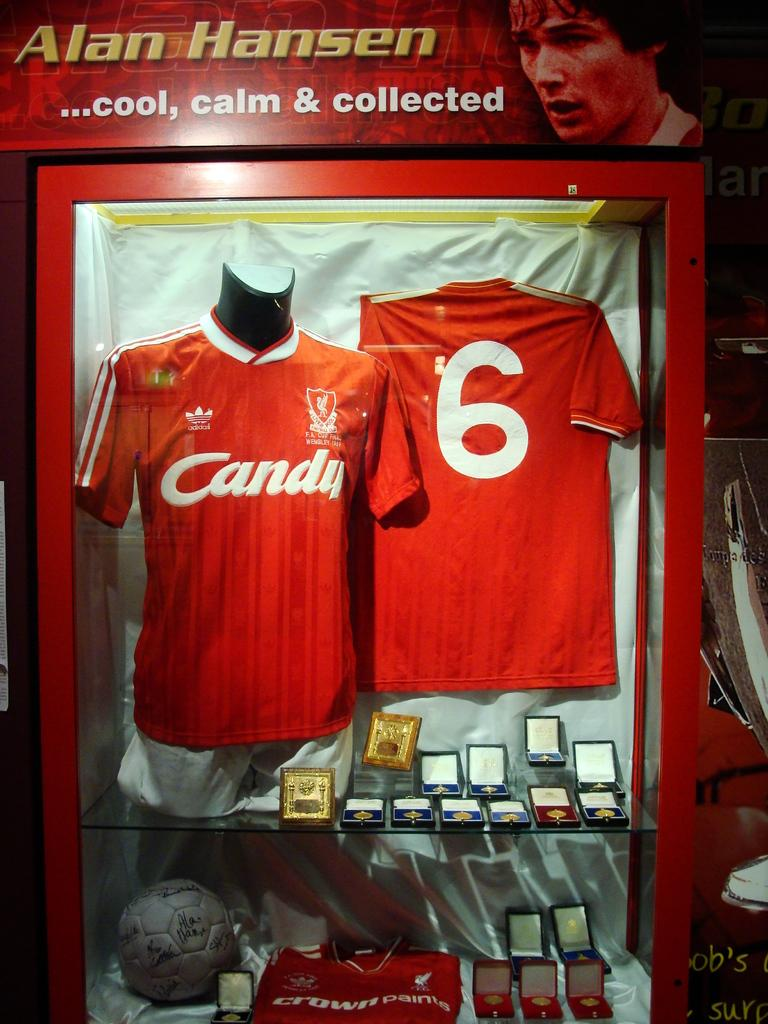<image>
Give a short and clear explanation of the subsequent image. A framed case with a soccer uniform that reads candy in the front and the number 6 in the back of the jersey. 